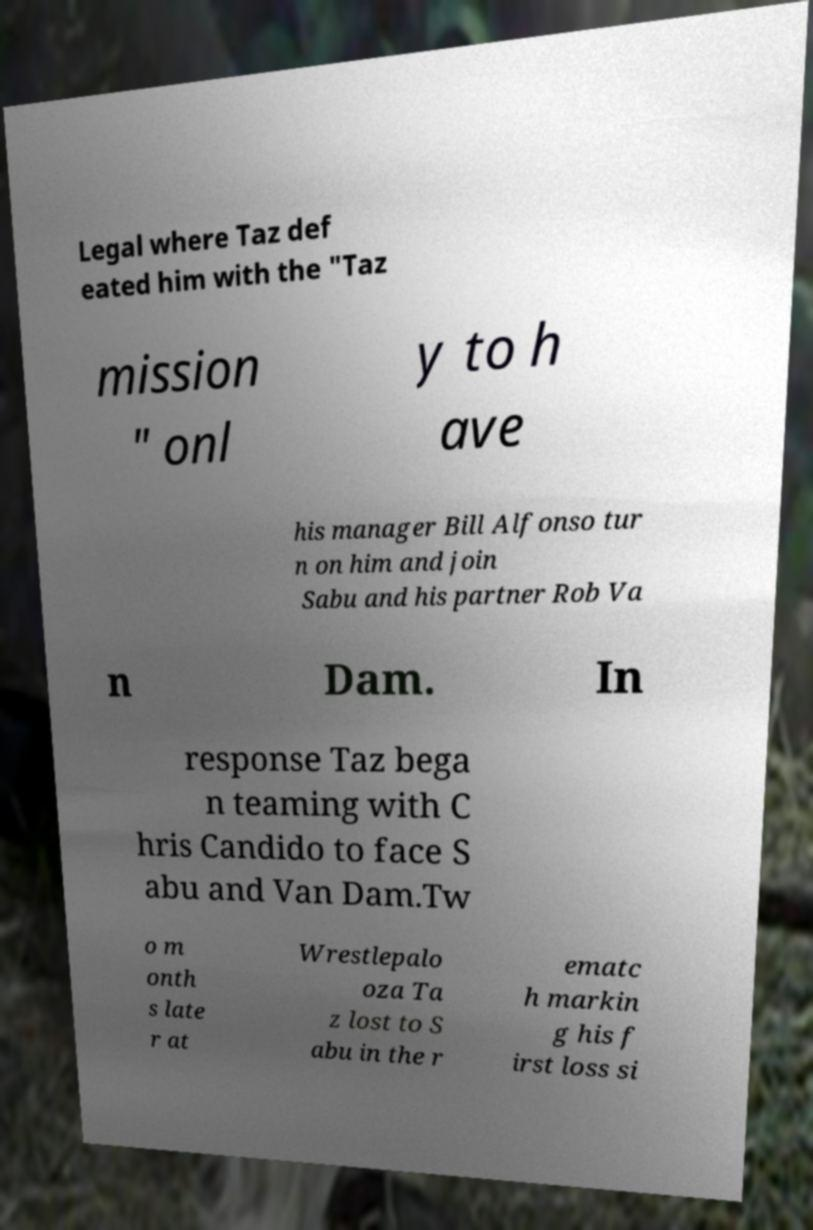What messages or text are displayed in this image? I need them in a readable, typed format. Legal where Taz def eated him with the "Taz mission " onl y to h ave his manager Bill Alfonso tur n on him and join Sabu and his partner Rob Va n Dam. In response Taz bega n teaming with C hris Candido to face S abu and Van Dam.Tw o m onth s late r at Wrestlepalo oza Ta z lost to S abu in the r ematc h markin g his f irst loss si 